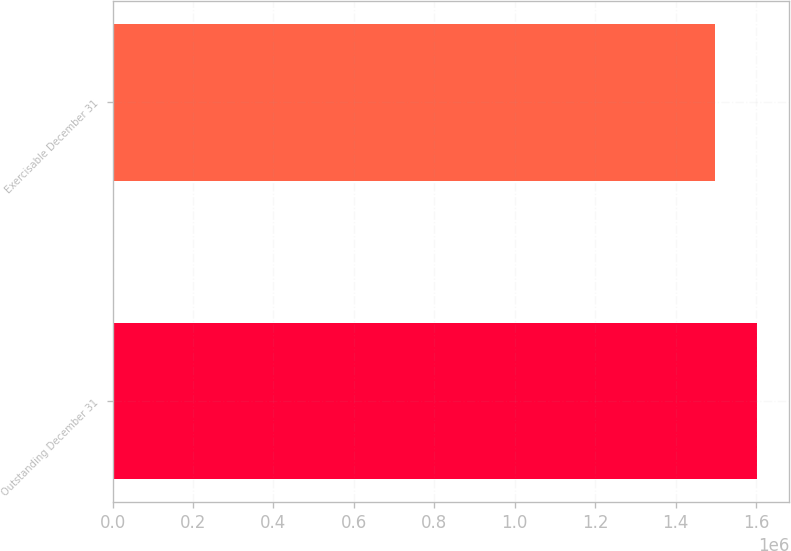Convert chart to OTSL. <chart><loc_0><loc_0><loc_500><loc_500><bar_chart><fcel>Outstanding December 31<fcel>Exercisable December 31<nl><fcel>1.60178e+06<fcel>1.49799e+06<nl></chart> 